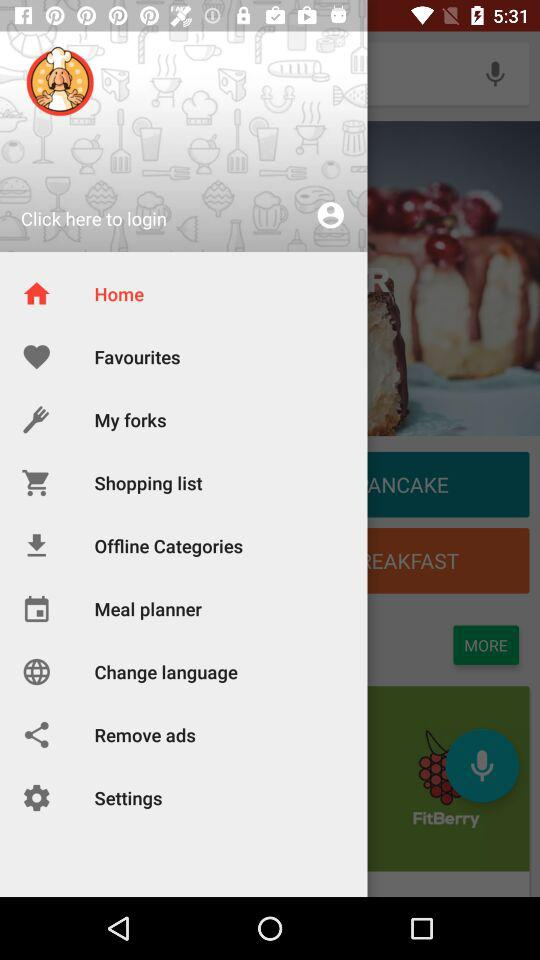Which item is selected? The item "Home" is selected. 